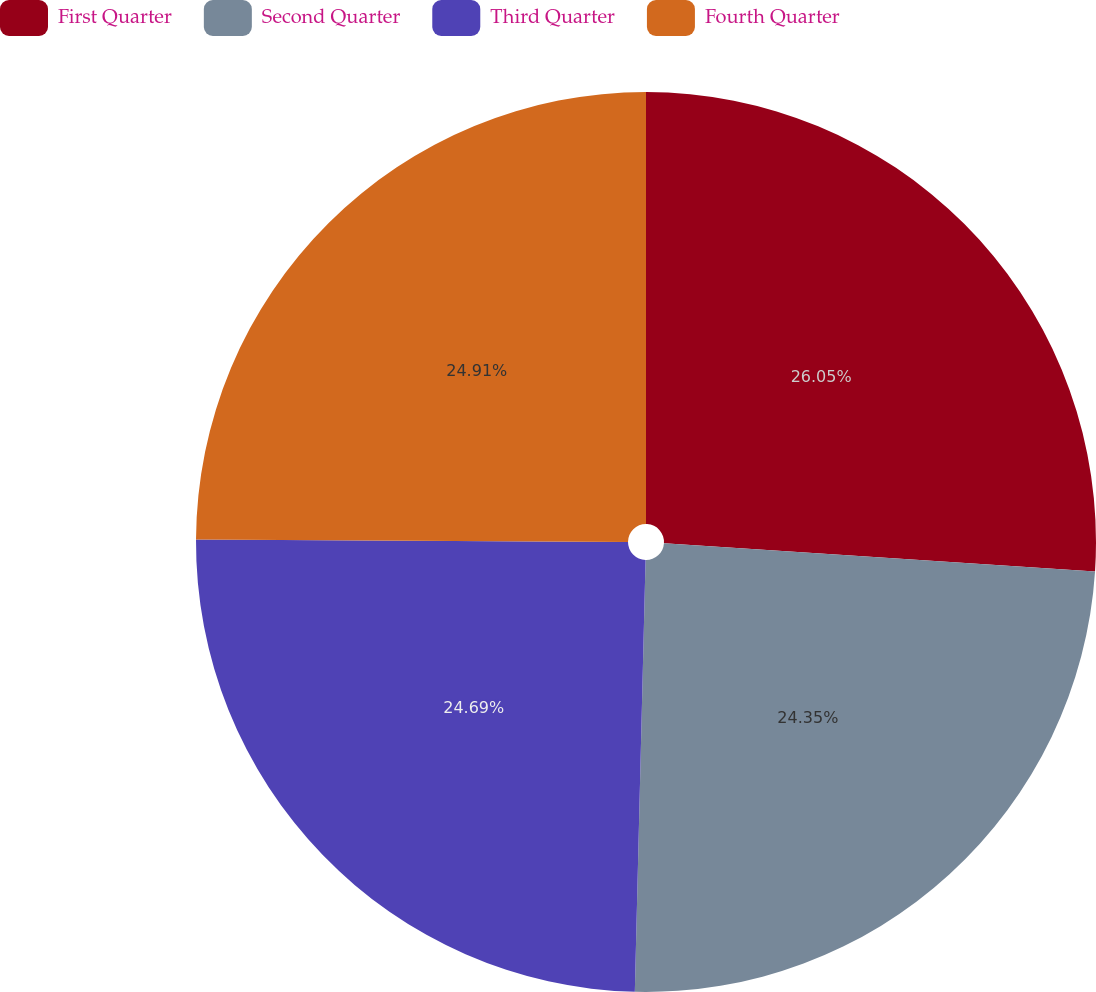<chart> <loc_0><loc_0><loc_500><loc_500><pie_chart><fcel>First Quarter<fcel>Second Quarter<fcel>Third Quarter<fcel>Fourth Quarter<nl><fcel>26.04%<fcel>24.35%<fcel>24.69%<fcel>24.91%<nl></chart> 